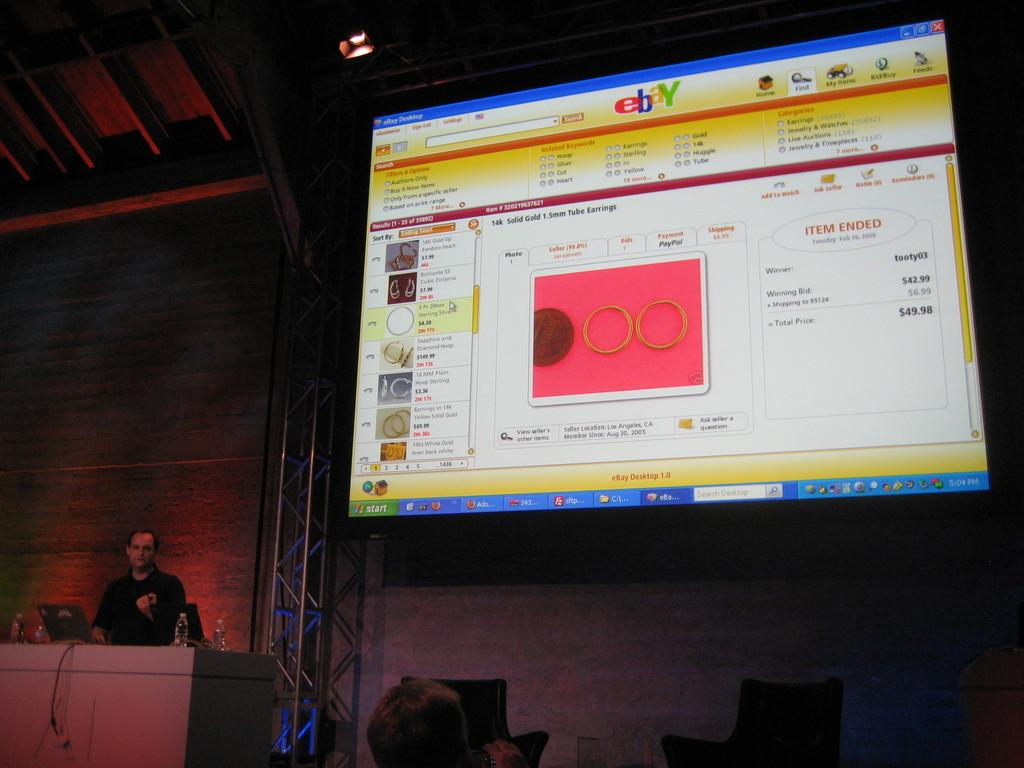<image>
Write a terse but informative summary of the picture. A man speaking to a group and standing in front of a large screen displaying an Ebay page. 